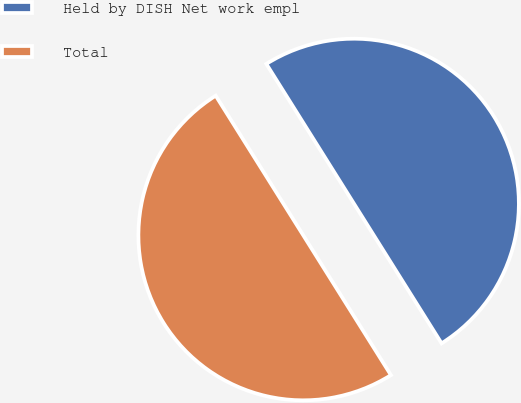Convert chart. <chart><loc_0><loc_0><loc_500><loc_500><pie_chart><fcel>Held by DISH Net work empl<fcel>Total<nl><fcel>50.0%<fcel>50.0%<nl></chart> 